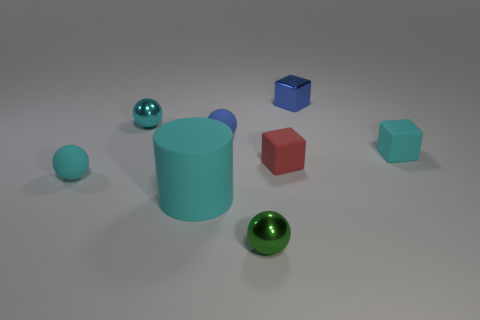Subtract all rubber blocks. How many blocks are left? 1 Subtract all green spheres. How many spheres are left? 3 Add 2 large green rubber cylinders. How many objects exist? 10 Subtract all cubes. How many objects are left? 5 Subtract all blue shiny objects. Subtract all small blue objects. How many objects are left? 5 Add 8 shiny blocks. How many shiny blocks are left? 9 Add 6 large cyan matte cylinders. How many large cyan matte cylinders exist? 7 Subtract 0 gray blocks. How many objects are left? 8 Subtract all gray cubes. Subtract all green cylinders. How many cubes are left? 3 Subtract all red cylinders. How many purple cubes are left? 0 